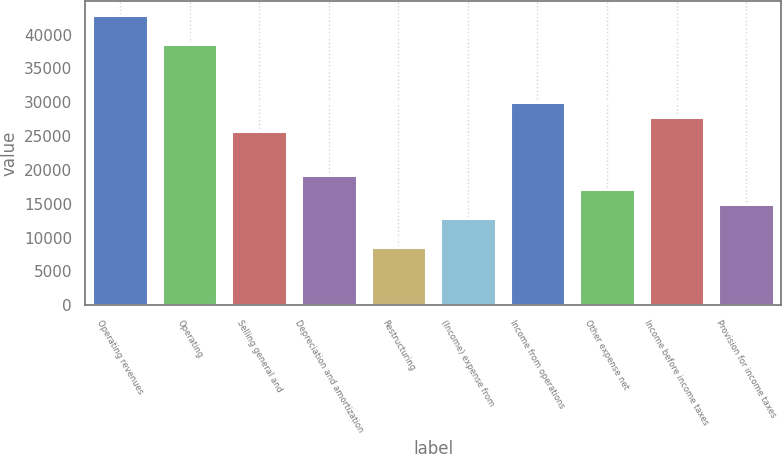Convert chart. <chart><loc_0><loc_0><loc_500><loc_500><bar_chart><fcel>Operating revenues<fcel>Operating<fcel>Selling general and<fcel>Depreciation and amortization<fcel>Restructuring<fcel>(Income) expense from<fcel>Income from operations<fcel>Other expense net<fcel>Income before income taxes<fcel>Provision for income taxes<nl><fcel>42822.5<fcel>38540.4<fcel>25694.1<fcel>19271<fcel>8565.7<fcel>12847.8<fcel>29976.2<fcel>17129.9<fcel>27835.2<fcel>14988.9<nl></chart> 